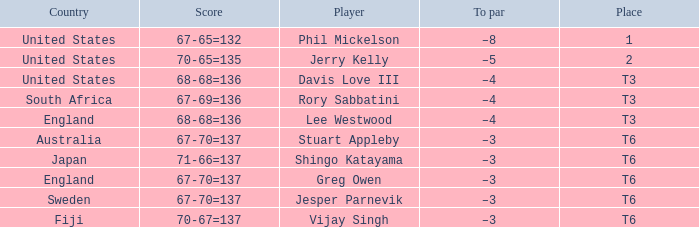Name the place for score of 67-70=137 and stuart appleby T6. 